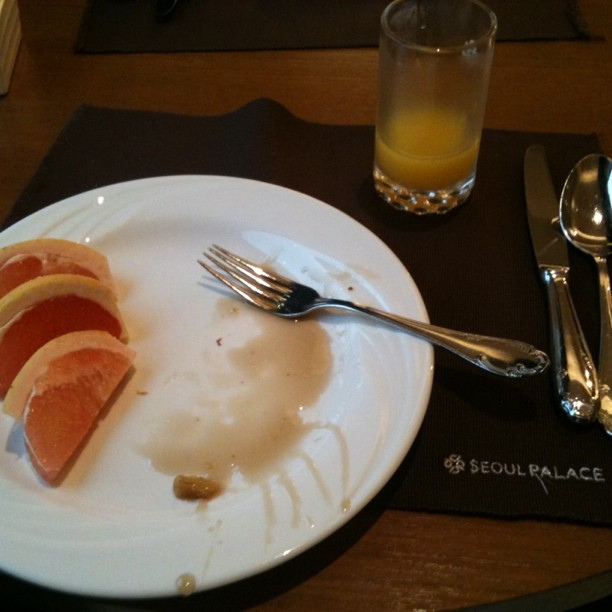<image>What restaurant is this at? I am not sure what restaurant this is at, but it could be Seoul Palace. What restaurant is this at? I am not sure what restaurant is this at. However, it can be seen 'seoul palace' or 'seoul place'. 